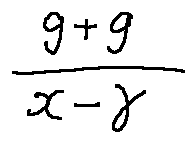<formula> <loc_0><loc_0><loc_500><loc_500>\frac { g + g } { x - \gamma }</formula> 